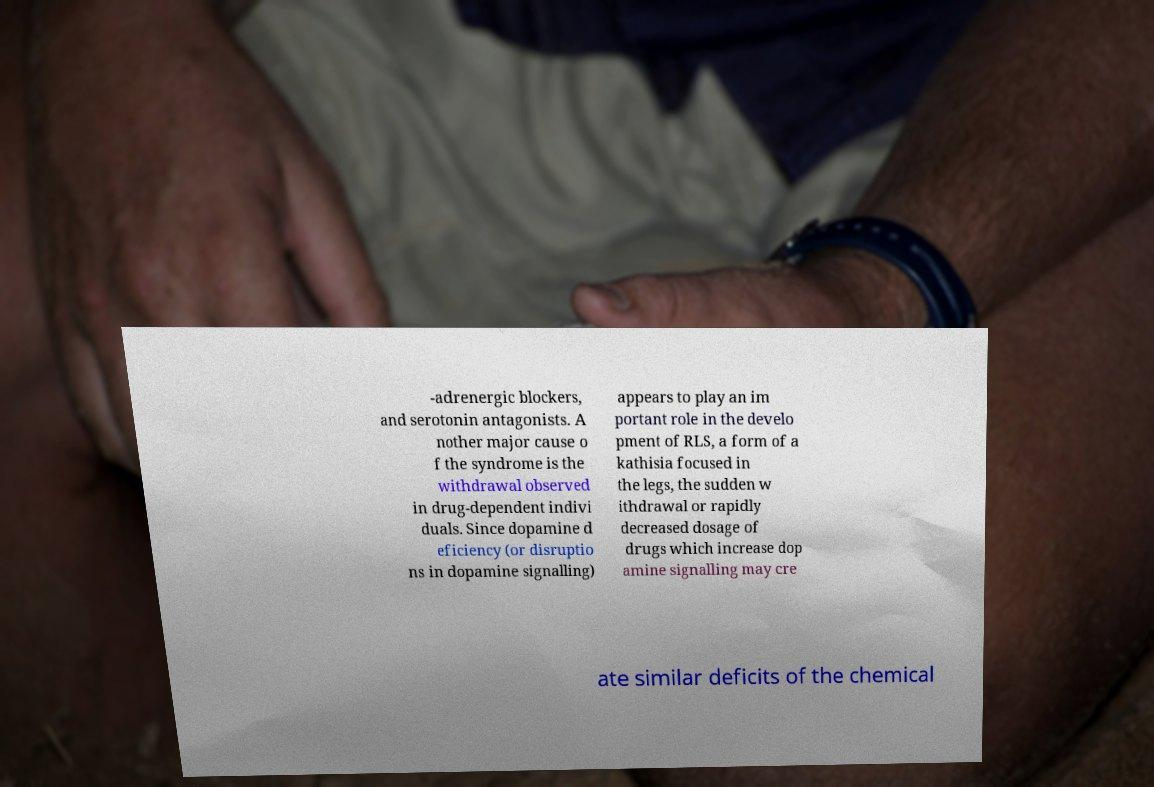There's text embedded in this image that I need extracted. Can you transcribe it verbatim? -adrenergic blockers, and serotonin antagonists. A nother major cause o f the syndrome is the withdrawal observed in drug-dependent indivi duals. Since dopamine d eficiency (or disruptio ns in dopamine signalling) appears to play an im portant role in the develo pment of RLS, a form of a kathisia focused in the legs, the sudden w ithdrawal or rapidly decreased dosage of drugs which increase dop amine signalling may cre ate similar deficits of the chemical 